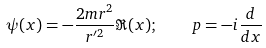<formula> <loc_0><loc_0><loc_500><loc_500>\psi ( x ) = - \frac { 2 m r ^ { 2 } } { r ^ { \prime 2 } } \Re ( x ) ; \quad p = - i \frac { d } { d x }</formula> 